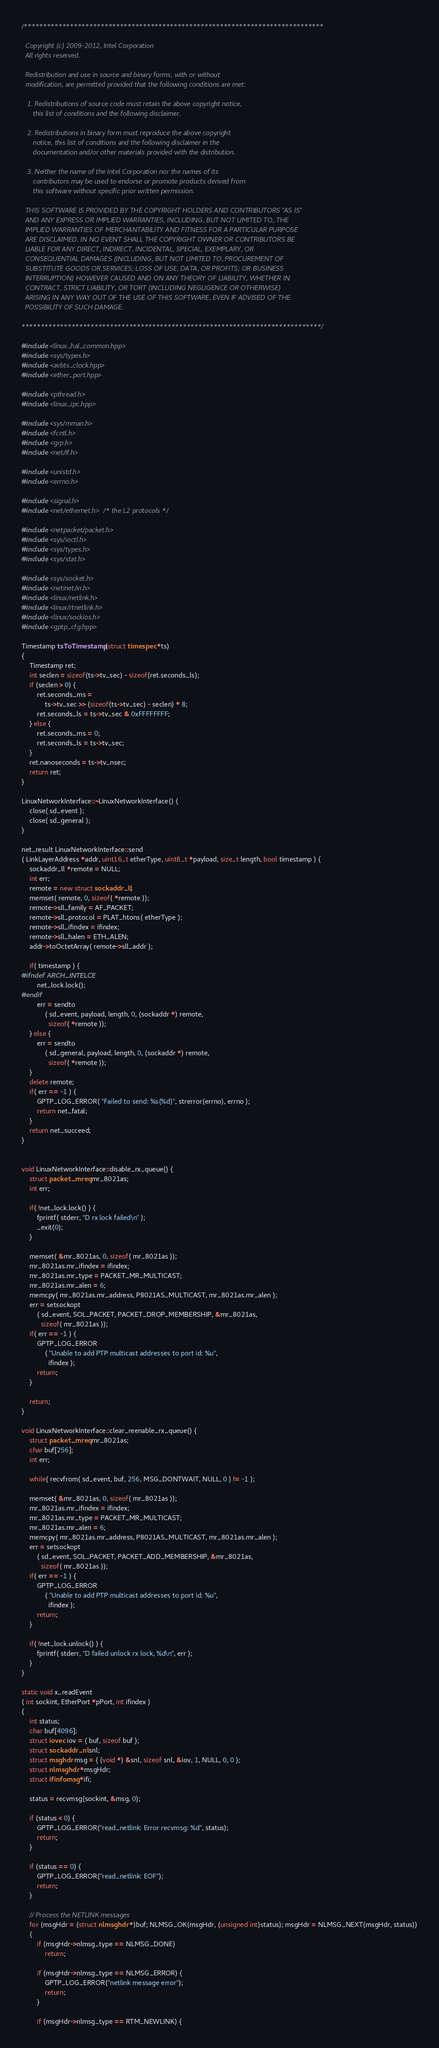<code> <loc_0><loc_0><loc_500><loc_500><_C++_>/******************************************************************************

  Copyright (c) 2009-2012, Intel Corporation
  All rights reserved.

  Redistribution and use in source and binary forms, with or without
  modification, are permitted provided that the following conditions are met:

   1. Redistributions of source code must retain the above copyright notice,
      this list of conditions and the following disclaimer.

   2. Redistributions in binary form must reproduce the above copyright
      notice, this list of conditions and the following disclaimer in the
      documentation and/or other materials provided with the distribution.

   3. Neither the name of the Intel Corporation nor the names of its
      contributors may be used to endorse or promote products derived from
      this software without specific prior written permission.

  THIS SOFTWARE IS PROVIDED BY THE COPYRIGHT HOLDERS AND CONTRIBUTORS "AS IS"
  AND ANY EXPRESS OR IMPLIED WARRANTIES, INCLUDING, BUT NOT LIMITED TO, THE
  IMPLIED WARRANTIES OF MERCHANTABILITY AND FITNESS FOR A PARTICULAR PURPOSE
  ARE DISCLAIMED. IN NO EVENT SHALL THE COPYRIGHT OWNER OR CONTRIBUTORS BE
  LIABLE FOR ANY DIRECT, INDIRECT, INCIDENTAL, SPECIAL, EXEMPLARY, OR
  CONSEQUENTIAL DAMAGES (INCLUDING, BUT NOT LIMITED TO, PROCUREMENT OF
  SUBSTITUTE GOODS OR SERVICES; LOSS OF USE, DATA, OR PROFITS; OR BUSINESS
  INTERRUPTION) HOWEVER CAUSED AND ON ANY THEORY OF LIABILITY, WHETHER IN
  CONTRACT, STRICT LIABILITY, OR TORT (INCLUDING NEGLIGENCE OR OTHERWISE)
  ARISING IN ANY WAY OUT OF THE USE OF THIS SOFTWARE, EVEN IF ADVISED OF THE
  POSSIBILITY OF SUCH DAMAGE.

******************************************************************************/

#include <linux_hal_common.hpp>
#include <sys/types.h>
#include <avbts_clock.hpp>
#include <ether_port.hpp>

#include <pthread.h>
#include <linux_ipc.hpp>

#include <sys/mman.h>
#include <fcntl.h>
#include <grp.h>
#include <net/if.h>

#include <unistd.h>
#include <errno.h>

#include <signal.h>
#include <net/ethernet.h> /* the L2 protocols */

#include <netpacket/packet.h>
#include <sys/ioctl.h>
#include <sys/types.h>
#include <sys/stat.h>

#include <sys/socket.h>
#include <netinet/in.h>
#include <linux/netlink.h>
#include <linux/rtnetlink.h>
#include <linux/sockios.h>
#include <gptp_cfg.hpp>

Timestamp tsToTimestamp(struct timespec *ts)
{
	Timestamp ret;
	int seclen = sizeof(ts->tv_sec) - sizeof(ret.seconds_ls);
	if (seclen > 0) {
		ret.seconds_ms =
		    ts->tv_sec >> (sizeof(ts->tv_sec) - seclen) * 8;
		ret.seconds_ls = ts->tv_sec & 0xFFFFFFFF;
	} else {
		ret.seconds_ms = 0;
		ret.seconds_ls = ts->tv_sec;
	}
	ret.nanoseconds = ts->tv_nsec;
	return ret;
}

LinuxNetworkInterface::~LinuxNetworkInterface() {
	close( sd_event );
	close( sd_general );
}

net_result LinuxNetworkInterface::send
( LinkLayerAddress *addr, uint16_t etherType, uint8_t *payload, size_t length, bool timestamp ) {
	sockaddr_ll *remote = NULL;
	int err;
	remote = new struct sockaddr_ll;
	memset( remote, 0, sizeof( *remote ));
	remote->sll_family = AF_PACKET;
	remote->sll_protocol = PLAT_htons( etherType );
	remote->sll_ifindex = ifindex;
	remote->sll_halen = ETH_ALEN;
	addr->toOctetArray( remote->sll_addr );

	if( timestamp ) {
#ifndef ARCH_INTELCE
		net_lock.lock();
#endif
		err = sendto
			( sd_event, payload, length, 0, (sockaddr *) remote,
			  sizeof( *remote ));
	} else {
		err = sendto
			( sd_general, payload, length, 0, (sockaddr *) remote,
			  sizeof( *remote ));
	}
	delete remote;
	if( err == -1 ) {
		GPTP_LOG_ERROR( "Failed to send: %s(%d)", strerror(errno), errno );
		return net_fatal;
	}
	return net_succeed;
}


void LinuxNetworkInterface::disable_rx_queue() {
	struct packet_mreq mr_8021as;
	int err;

	if( !net_lock.lock() ) {
		fprintf( stderr, "D rx lock failed\n" );
		_exit(0);
	}

	memset( &mr_8021as, 0, sizeof( mr_8021as ));
	mr_8021as.mr_ifindex = ifindex;
	mr_8021as.mr_type = PACKET_MR_MULTICAST;
	mr_8021as.mr_alen = 6;
	memcpy( mr_8021as.mr_address, P8021AS_MULTICAST, mr_8021as.mr_alen );
	err = setsockopt
		( sd_event, SOL_PACKET, PACKET_DROP_MEMBERSHIP, &mr_8021as,
		  sizeof( mr_8021as ));
	if( err == -1 ) {
		GPTP_LOG_ERROR
			( "Unable to add PTP multicast addresses to port id: %u",
			  ifindex );
		return;
	}

	return;
}

void LinuxNetworkInterface::clear_reenable_rx_queue() {
	struct packet_mreq mr_8021as;
	char buf[256];
	int err;

	while( recvfrom( sd_event, buf, 256, MSG_DONTWAIT, NULL, 0 ) != -1 );

	memset( &mr_8021as, 0, sizeof( mr_8021as ));
	mr_8021as.mr_ifindex = ifindex;
	mr_8021as.mr_type = PACKET_MR_MULTICAST;
	mr_8021as.mr_alen = 6;
	memcpy( mr_8021as.mr_address, P8021AS_MULTICAST, mr_8021as.mr_alen );
	err = setsockopt
		( sd_event, SOL_PACKET, PACKET_ADD_MEMBERSHIP, &mr_8021as,
		  sizeof( mr_8021as ));
	if( err == -1 ) {
		GPTP_LOG_ERROR
			( "Unable to add PTP multicast addresses to port id: %u",
			  ifindex );
		return;
	}

	if( !net_lock.unlock() ) {
		fprintf( stderr, "D failed unlock rx lock, %d\n", err );
	}
}

static void x_readEvent
( int sockint, EtherPort *pPort, int ifindex )
{
	int status;
	char buf[4096];
	struct iovec iov = { buf, sizeof buf };
	struct sockaddr_nl snl;
	struct msghdr msg = { (void *) &snl, sizeof snl, &iov, 1, NULL, 0, 0 };
	struct nlmsghdr *msgHdr;
	struct ifinfomsg *ifi;

	status = recvmsg(sockint, &msg, 0);

	if (status < 0) {
		GPTP_LOG_ERROR("read_netlink: Error recvmsg: %d", status);
		return;
	}

	if (status == 0) {
		GPTP_LOG_ERROR("read_netlink: EOF");
		return;
	}

	// Process the NETLINK messages
	for (msgHdr = (struct nlmsghdr *)buf; NLMSG_OK(msgHdr, (unsigned int)status); msgHdr = NLMSG_NEXT(msgHdr, status))
	{
		if (msgHdr->nlmsg_type == NLMSG_DONE)
			return;

		if (msgHdr->nlmsg_type == NLMSG_ERROR) {
			GPTP_LOG_ERROR("netlink message error");
			return;
		}

		if (msgHdr->nlmsg_type == RTM_NEWLINK) {</code> 